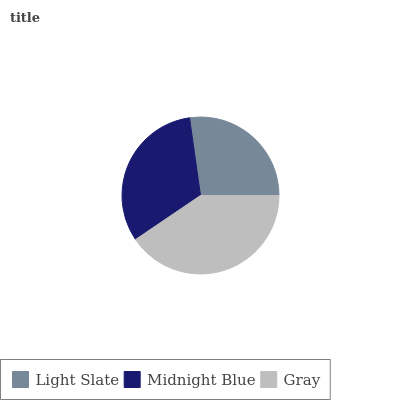Is Light Slate the minimum?
Answer yes or no. Yes. Is Gray the maximum?
Answer yes or no. Yes. Is Midnight Blue the minimum?
Answer yes or no. No. Is Midnight Blue the maximum?
Answer yes or no. No. Is Midnight Blue greater than Light Slate?
Answer yes or no. Yes. Is Light Slate less than Midnight Blue?
Answer yes or no. Yes. Is Light Slate greater than Midnight Blue?
Answer yes or no. No. Is Midnight Blue less than Light Slate?
Answer yes or no. No. Is Midnight Blue the high median?
Answer yes or no. Yes. Is Midnight Blue the low median?
Answer yes or no. Yes. Is Gray the high median?
Answer yes or no. No. Is Light Slate the low median?
Answer yes or no. No. 